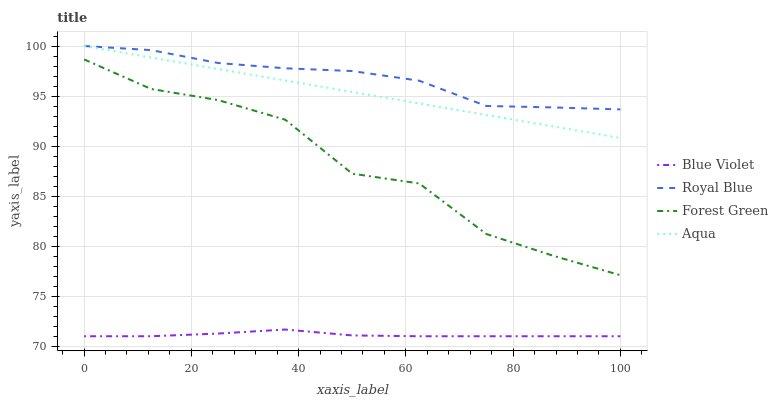Does Blue Violet have the minimum area under the curve?
Answer yes or no. Yes. Does Royal Blue have the maximum area under the curve?
Answer yes or no. Yes. Does Forest Green have the minimum area under the curve?
Answer yes or no. No. Does Forest Green have the maximum area under the curve?
Answer yes or no. No. Is Aqua the smoothest?
Answer yes or no. Yes. Is Forest Green the roughest?
Answer yes or no. Yes. Is Forest Green the smoothest?
Answer yes or no. No. Is Aqua the roughest?
Answer yes or no. No. Does Blue Violet have the lowest value?
Answer yes or no. Yes. Does Forest Green have the lowest value?
Answer yes or no. No. Does Aqua have the highest value?
Answer yes or no. Yes. Does Forest Green have the highest value?
Answer yes or no. No. Is Blue Violet less than Aqua?
Answer yes or no. Yes. Is Royal Blue greater than Blue Violet?
Answer yes or no. Yes. Does Aqua intersect Royal Blue?
Answer yes or no. Yes. Is Aqua less than Royal Blue?
Answer yes or no. No. Is Aqua greater than Royal Blue?
Answer yes or no. No. Does Blue Violet intersect Aqua?
Answer yes or no. No. 